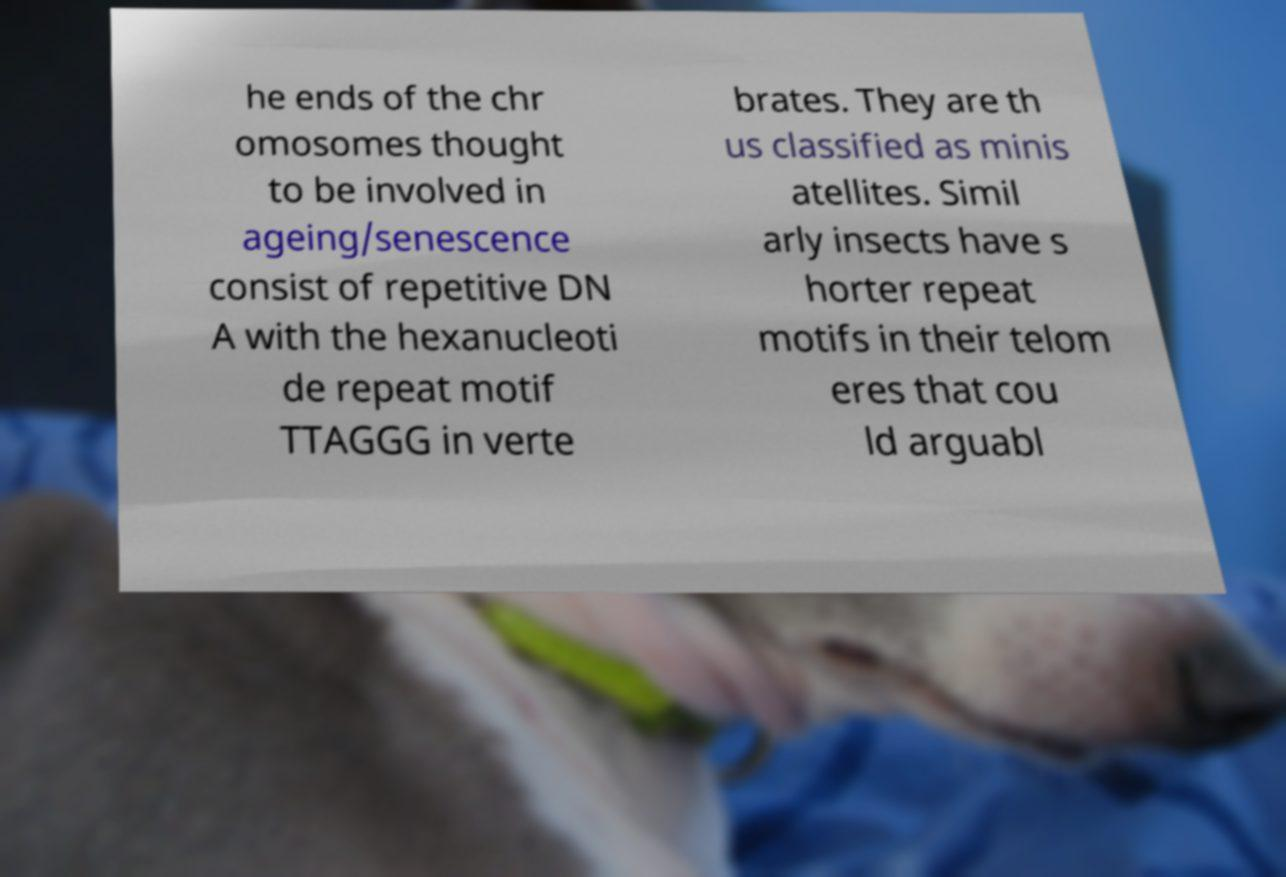Can you read and provide the text displayed in the image?This photo seems to have some interesting text. Can you extract and type it out for me? he ends of the chr omosomes thought to be involved in ageing/senescence consist of repetitive DN A with the hexanucleoti de repeat motif TTAGGG in verte brates. They are th us classified as minis atellites. Simil arly insects have s horter repeat motifs in their telom eres that cou ld arguabl 